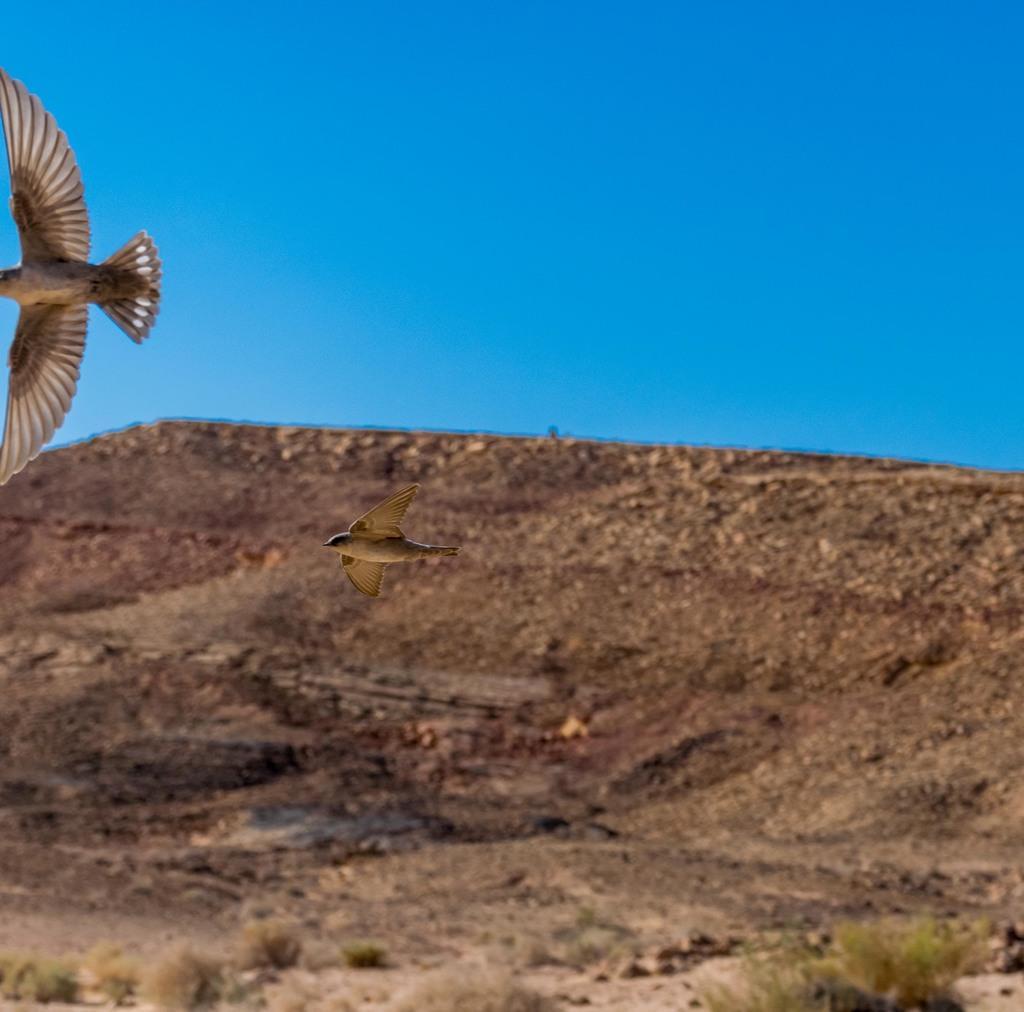Can you describe this image briefly? In this image, we can see birds above the ground. There is a sky at the top of the image. 